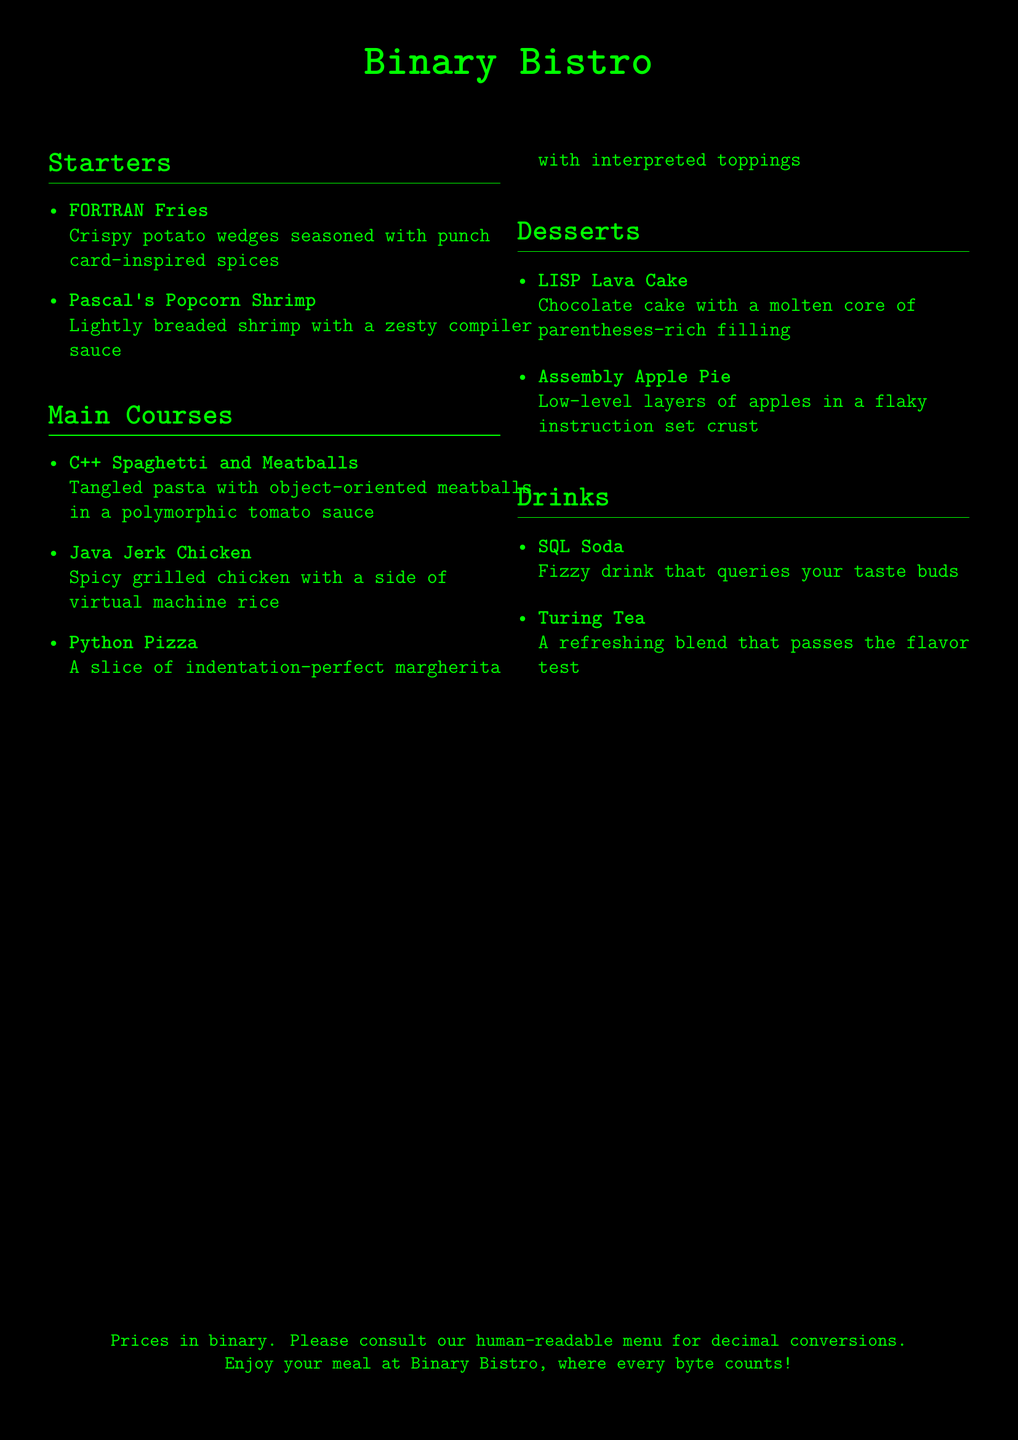What is the name of the restaurant? The title at the top of the menu indicates the restaurant's name as "Binary Bistro."
Answer: Binary Bistro How many sections are in the menu? The menu consists of four distinct sections: Starters, Main Courses, Desserts, and Drinks.
Answer: Four What is the first item listed under Starters? The first item under the Starters section is clearly stated as "FORTRAN Fries."
Answer: FORTRAN Fries What unique feature accompanies the menus' prices? The document specifies that the prices are presented in binary, with a note to consult a human-readable menu for decimal conversions.
Answer: Binary Which dish includes a molten filling? The dessert with a molten core is identified as "LISP Lava Cake."
Answer: LISP Lava Cake What cooking style is used for the chicken dish? The description of the chicken dish indicates it is "spicy grilled," which denotes the cooking style used.
Answer: Spicy grilled What is the inspiration behind the fries' seasoning? The fries are seasoned with spices inspired by punch cards, suggesting a unique theme linked to early computing history.
Answer: Punch card-inspired spices Which main course has a tomato sauce? The dish "C++ Spaghetti and Meatballs" is clearly stated to be served with a "polymorphic tomato sauce."
Answer: Polymorphic tomato sauce What kind of drink is SQL Soda? The drink is described as a fizzy beverage that queries the customer's taste buds, emphasizing its refreshing quality.
Answer: Fizzy drink 